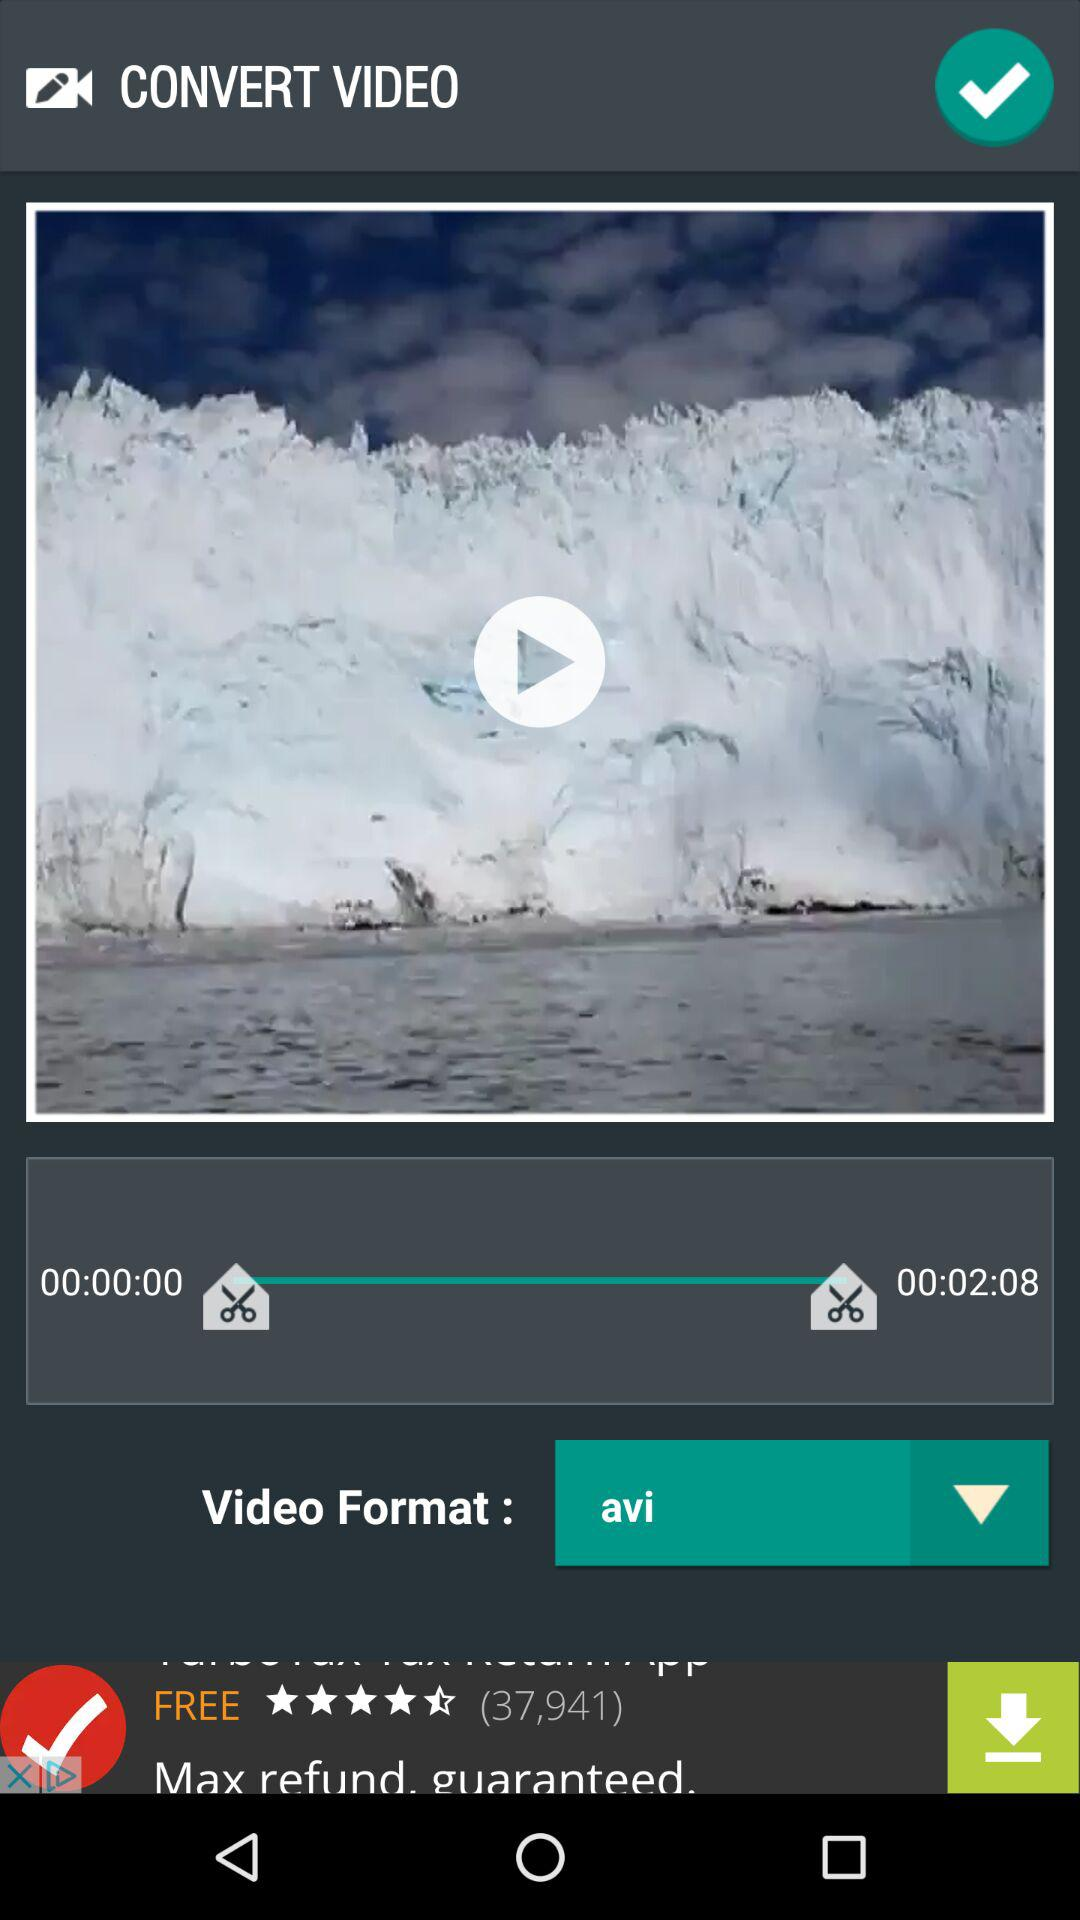What is the selected video format? The selected video format is "avi". 